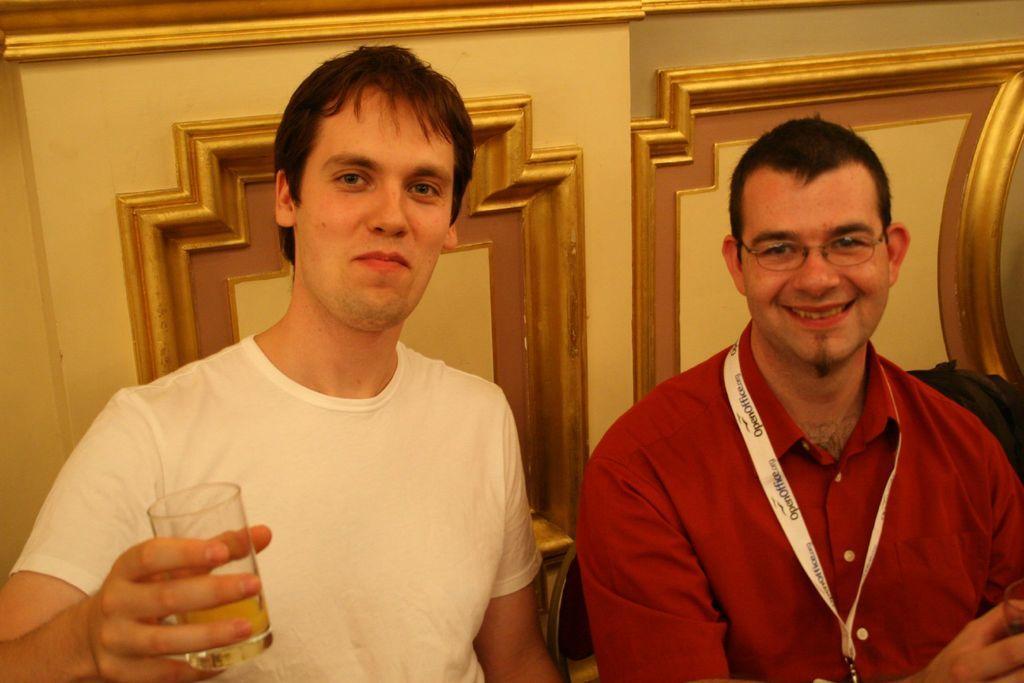Describe this image in one or two sentences. In this image there are two men. They are smiling. They are holding glasses in their hands. The man to the right is wearing a tag around his neck. There is text on the tag. Behind him there is the wall. 